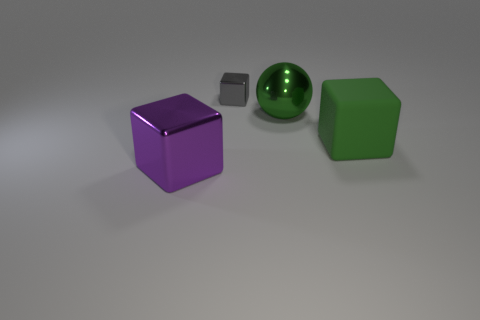Is there a gray matte ball of the same size as the purple cube?
Your response must be concise. No. What material is the other block that is the same size as the purple metallic block?
Give a very brief answer. Rubber. There is a large thing that is left of the tiny gray block; what is its shape?
Ensure brevity in your answer.  Cube. Do the cube behind the green sphere and the cube right of the metallic ball have the same material?
Provide a short and direct response. No. What number of large green shiny objects have the same shape as the purple object?
Provide a short and direct response. 0. There is a large cube that is the same color as the sphere; what is it made of?
Provide a succinct answer. Rubber. What number of objects are tiny gray things or cubes right of the big purple thing?
Ensure brevity in your answer.  2. What material is the big green cube?
Provide a short and direct response. Rubber. There is another large thing that is the same shape as the large purple metallic object; what is it made of?
Ensure brevity in your answer.  Rubber. What is the color of the big block that is on the right side of the big thing in front of the large matte cube?
Provide a short and direct response. Green. 